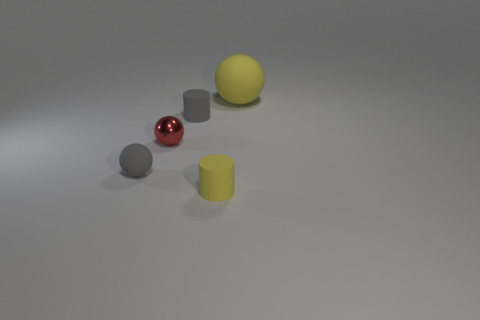How many other objects are there of the same color as the big sphere?
Provide a short and direct response. 1. Does the object in front of the gray ball have the same size as the yellow matte object that is to the right of the tiny yellow matte thing?
Offer a terse response. No. Does the large yellow sphere have the same material as the tiny sphere behind the small gray rubber ball?
Your answer should be very brief. No. Is the number of yellow matte things in front of the red thing greater than the number of things that are behind the large yellow thing?
Offer a terse response. Yes. There is a matte sphere to the left of the yellow object that is behind the gray ball; what is its color?
Your answer should be compact. Gray. What number of blocks are either shiny things or tiny yellow things?
Ensure brevity in your answer.  0. What number of small objects are behind the tiny matte sphere and on the right side of the small shiny sphere?
Your response must be concise. 1. There is a small thing behind the small red metallic ball; what color is it?
Make the answer very short. Gray. There is a yellow sphere that is made of the same material as the gray cylinder; what size is it?
Your answer should be compact. Large. There is a yellow rubber object to the left of the large sphere; how many rubber objects are to the right of it?
Ensure brevity in your answer.  1. 